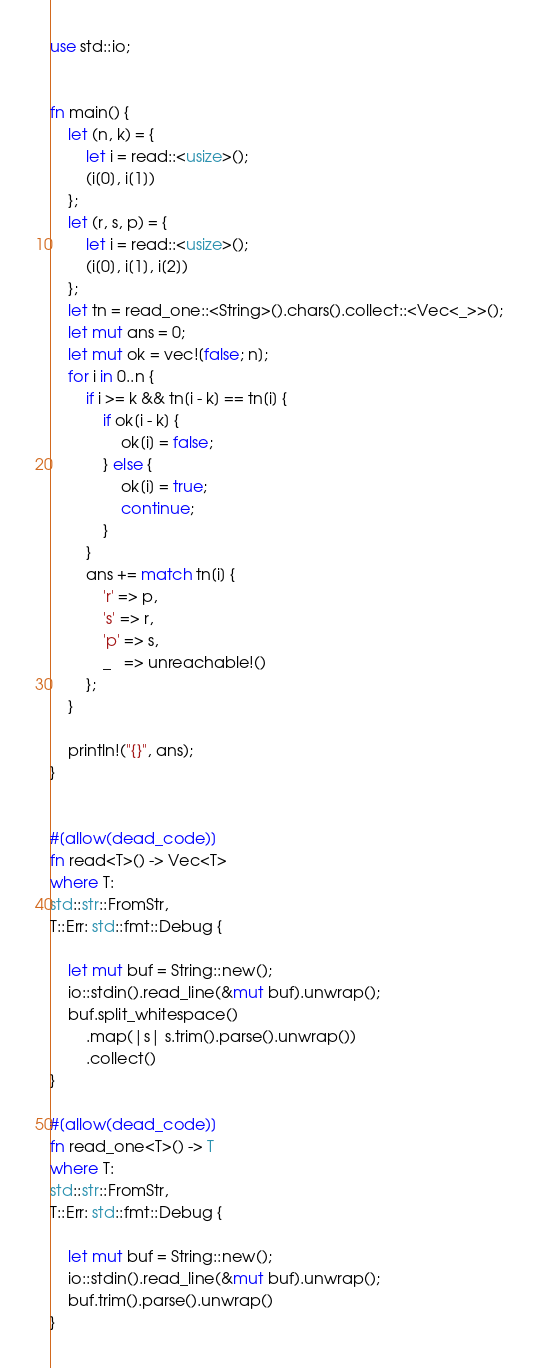<code> <loc_0><loc_0><loc_500><loc_500><_Rust_>use std::io;


fn main() {
    let (n, k) = {
        let i = read::<usize>();
        (i[0], i[1])
    };
    let (r, s, p) = {
        let i = read::<usize>();
        (i[0], i[1], i[2])
    };
    let tn = read_one::<String>().chars().collect::<Vec<_>>();
    let mut ans = 0;
    let mut ok = vec![false; n];
    for i in 0..n {
        if i >= k && tn[i - k] == tn[i] {
            if ok[i - k] {
                ok[i] = false;
            } else {
                ok[i] = true;
                continue;
            }
        }
        ans += match tn[i] {
            'r' => p,
            's' => r,
            'p' => s,
            _   => unreachable!()
        };
    }

    println!("{}", ans);
}


#[allow(dead_code)]
fn read<T>() -> Vec<T>
where T:
std::str::FromStr,
T::Err: std::fmt::Debug {

    let mut buf = String::new();
    io::stdin().read_line(&mut buf).unwrap();
    buf.split_whitespace()
        .map(|s| s.trim().parse().unwrap())
        .collect()
}

#[allow(dead_code)]
fn read_one<T>() -> T
where T:
std::str::FromStr,
T::Err: std::fmt::Debug {

    let mut buf = String::new();
    io::stdin().read_line(&mut buf).unwrap();
    buf.trim().parse().unwrap()
}</code> 